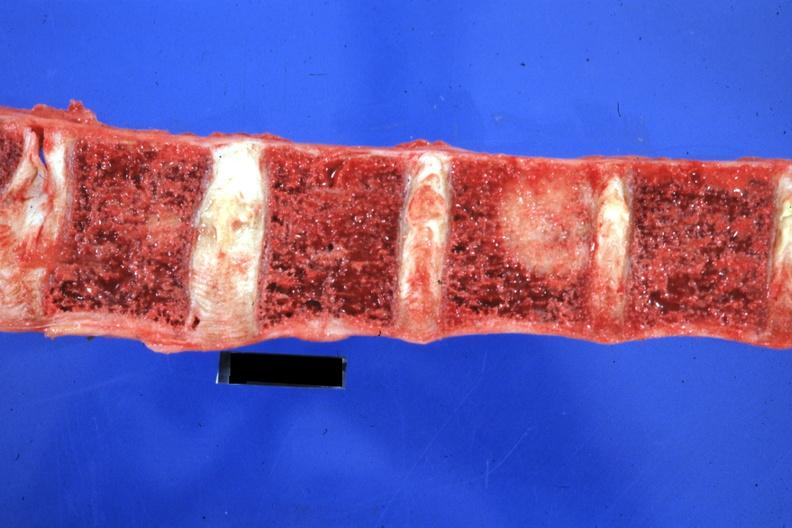what does this image show?
Answer the question using a single word or phrase. Close-up excellent primary tail of pancreas 